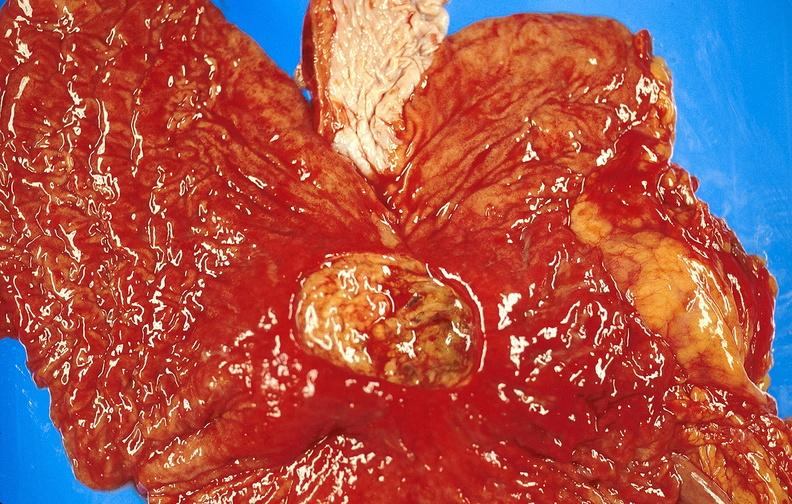where does this belong to?
Answer the question using a single word or phrase. Gastrointestinal system 